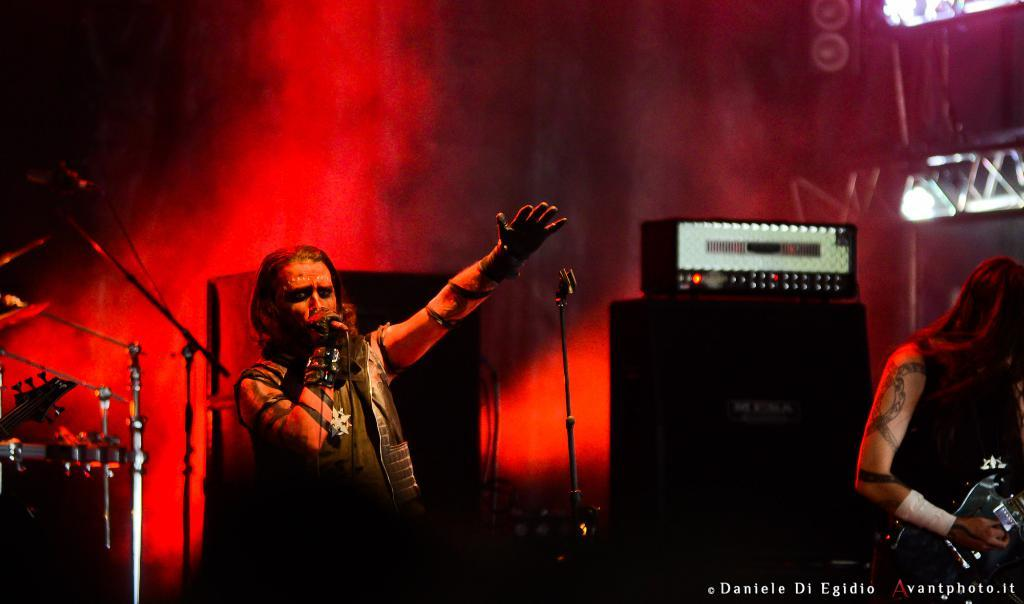What objects can be seen in the image? There are lights, a man holding a microphone, and another man holding a guitar in the image. What might the man with the microphone be doing? The man with the microphone might be singing or speaking into it. What is the man with the guitar doing? The man with the guitar is likely playing it or holding it to play it. Where is the father sitting with a loaf of bread in the image? There is no father or loaf of bread present in the image. What type of desk can be seen in the image? There is no desk present in the image. 